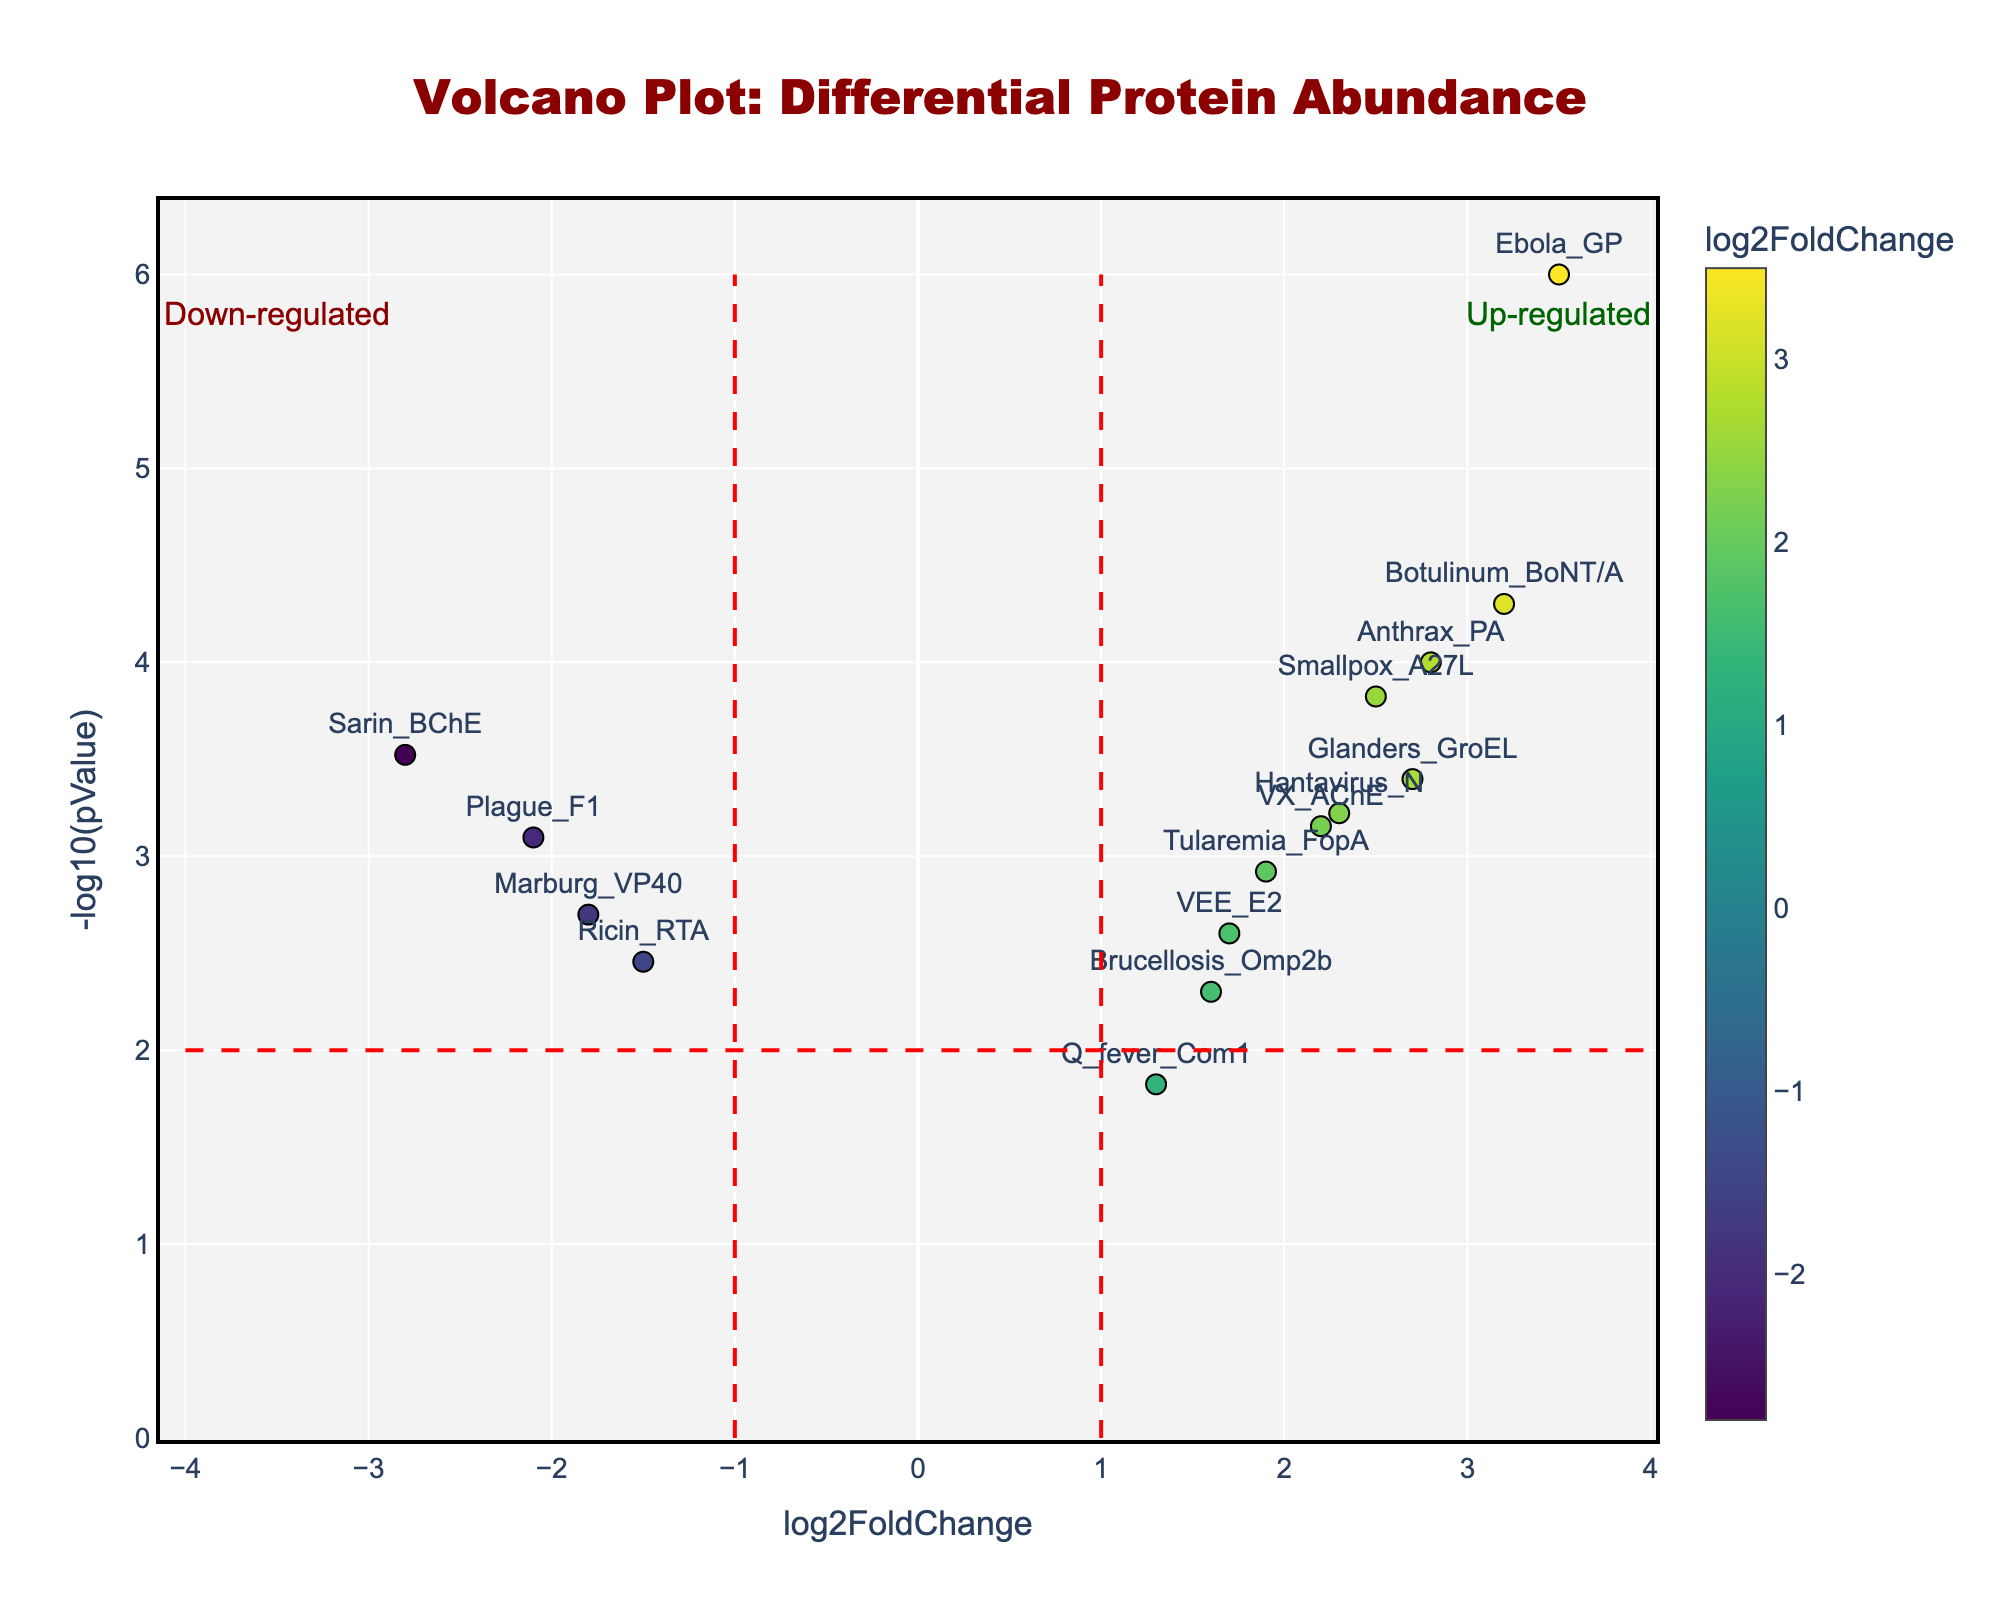What is the title of the figure? The title of the figure is displayed prominently at the top of the plot in a larger font size and bold red color.
Answer: Volcano Plot: Differential Protein Abundance Where are the most up-regulated proteins located on the plot? Up-regulated proteins have high positive log2FoldChange values. Looking at the title "Volcano Plot: Differential Protein Abundance," the up-regulated area is marked next to the right dashed red line.
Answer: Right side of the plot Which protein has the highest -log10(pValue)? To find the highest -log10(pValue), identify the data point with the highest vertical position. The label near the highest point is "Ebola_GP."
Answer: Ebola_GP How many proteins are down-regulated? Down-regulated proteins are located in the left half of the plot, having negative log2FoldChange values. A quick count based on the locations gives five down-regulated proteins.
Answer: 5 Which proteins have a log2FoldChange between 2 and 3? Identify data points within the range of log2FoldChange between 2 and 3 and read their labels: "Anthrax_PA," "VX_AChE," "Smallpox_A27L," and "Hantavirus_N."
Answer: Anthrax_PA, VX_AChE, Smallpox_A27L, Hantavirus_N Which protein has the most negative log2FoldChange and what is its -log10(pValue)? Find the leftmost point with the most negative log2FoldChange. The label beside this point is "Sarin_BChE". Refer to its vertical position to determine -log10(pValue).
Answer: Sarin_BChE; approximately 3.5 Is there a protein with a log2FoldChange of 0? Look along the x-axis at the 0 mark and check for any data point exactly at that position. There are no points directly at 0.
Answer: No Compare the log2FoldChange of Ricin_RTA and Tularemia_FopA. Which one is higher? Ricin_RTA has a log2FoldChange of -1.5 and Tularemia_FopA has a log2FoldChange of 1.9. Since 1.9 is greater than -1.5, Tularemia_FopA is higher.
Answer: Tularemia_FopA What are the thresholds indicated by the dashed red lines on the plot? The vertical dashed lines at log2FoldChange = -1 and 1, and a horizontal dashed line at -log10(pValue) = 2 act as thresholds for significance and regulation interpretation.
Answer: -1, 1 for log2FoldChange; 2 for -log10(pValue) Which protein appears at the top right corner of the plot? The top right corner corresponds to high log2FoldChange and high -log10(pValue) values. The label indicates "Ebola_GP."
Answer: Ebola_GP 